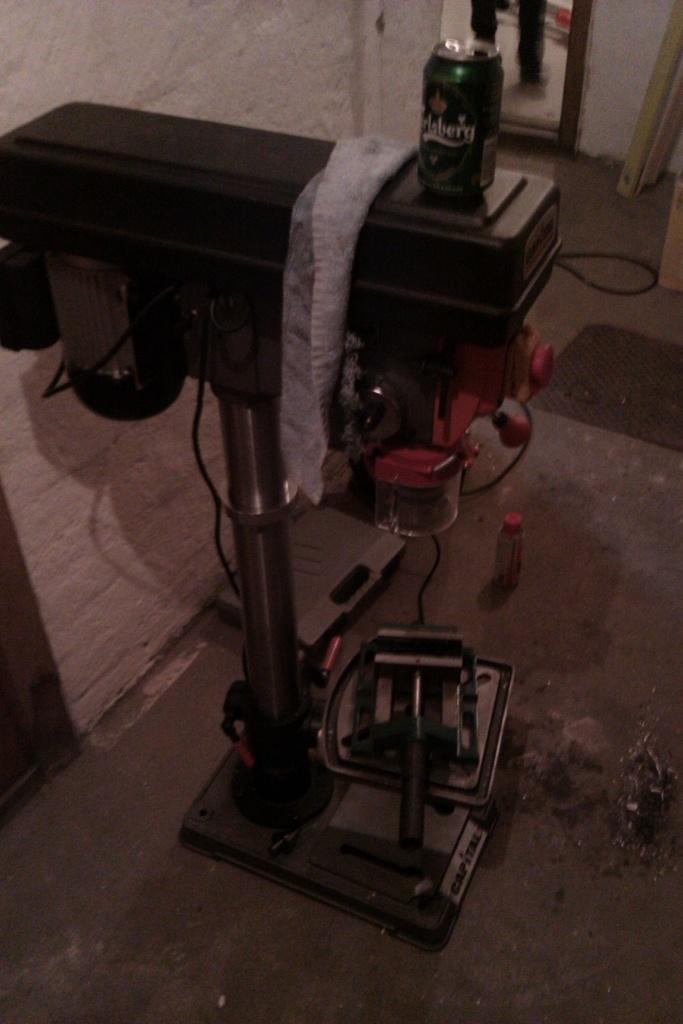What drink is in the can?
Offer a terse response. Carlsberg. 